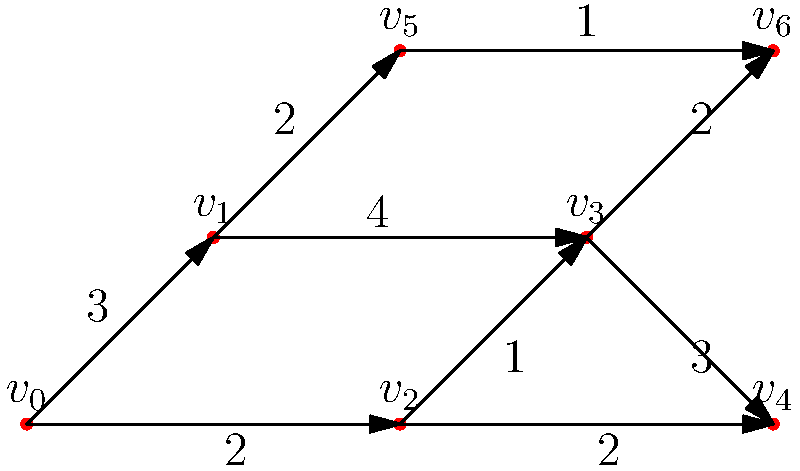As a film producer working with Lydia Hull, you're tasked with optimizing the scheduling of scenes across multiple movies. The directed acyclic graph represents the dependencies between scenes, where vertices are scenes and edge weights are the time (in days) needed between scenes. What is the minimum number of days required to complete all scenes, assuming multiple scenes can be shot simultaneously if there are no dependencies? To solve this problem, we need to find the longest path in the directed acyclic graph (DAG), also known as the critical path. This represents the sequence of scenes that will take the longest to complete and cannot be parallelized.

Step 1: Identify all paths from the start (v₀) to the end (v₄ or v₆):
- v₀ → v₁ → v₃ → v₄
- v₀ → v₁ → v₃ → v₆
- v₀ → v₁ → v₅ → v₆
- v₀ → v₂ → v₃ → v₄
- v₀ → v₂ → v₃ → v₆
- v₀ → v₂ → v₄

Step 2: Calculate the total weight (time) for each path:
- v₀ → v₁ → v₃ → v₄: 3 + 4 + 3 = 10 days
- v₀ → v₁ → v₃ → v₆: 3 + 4 + 2 = 9 days
- v₀ → v₁ → v₅ → v₆: 3 + 2 + 1 = 6 days
- v₀ → v₂ → v₃ → v₄: 2 + 1 + 3 = 6 days
- v₀ → v₂ → v₃ → v₆: 2 + 1 + 2 = 5 days
- v₀ → v₂ → v₄: 2 + 2 = 4 days

Step 3: Identify the longest path (critical path):
The longest path is v₀ → v₁ → v₃ → v₄, which takes 10 days.

Step 4: Verify that this is the minimum time required:
Since this is the critical path, no other combination of scenes can be completed faster, even if shot in parallel. All other scenes can be scheduled within this 10-day period without violating dependencies.
Answer: 10 days 